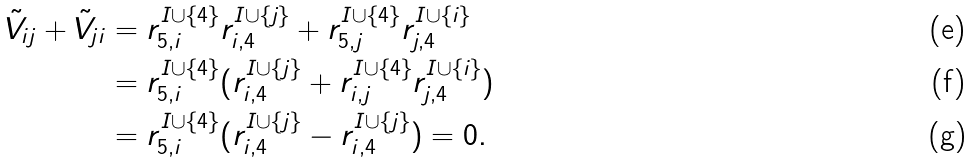Convert formula to latex. <formula><loc_0><loc_0><loc_500><loc_500>\tilde { V } _ { i j } + \tilde { V } _ { j i } & = r ^ { I \cup \{ 4 \} } _ { 5 , i } r ^ { I \cup \{ j \} } _ { i , 4 } + r ^ { I \cup \{ 4 \} } _ { 5 , j } r ^ { I \cup \{ i \} } _ { j , 4 } \\ & = r ^ { I \cup \{ 4 \} } _ { 5 , i } ( r ^ { I \cup \{ j \} } _ { i , 4 } + r ^ { I \cup \{ 4 \} } _ { i , j } r ^ { I \cup \{ i \} } _ { j , 4 } ) \\ & = r ^ { I \cup \{ 4 \} } _ { 5 , i } ( r ^ { I \cup \{ j \} } _ { i , 4 } - r ^ { I \cup \{ j \} } _ { i , 4 } ) = 0 .</formula> 